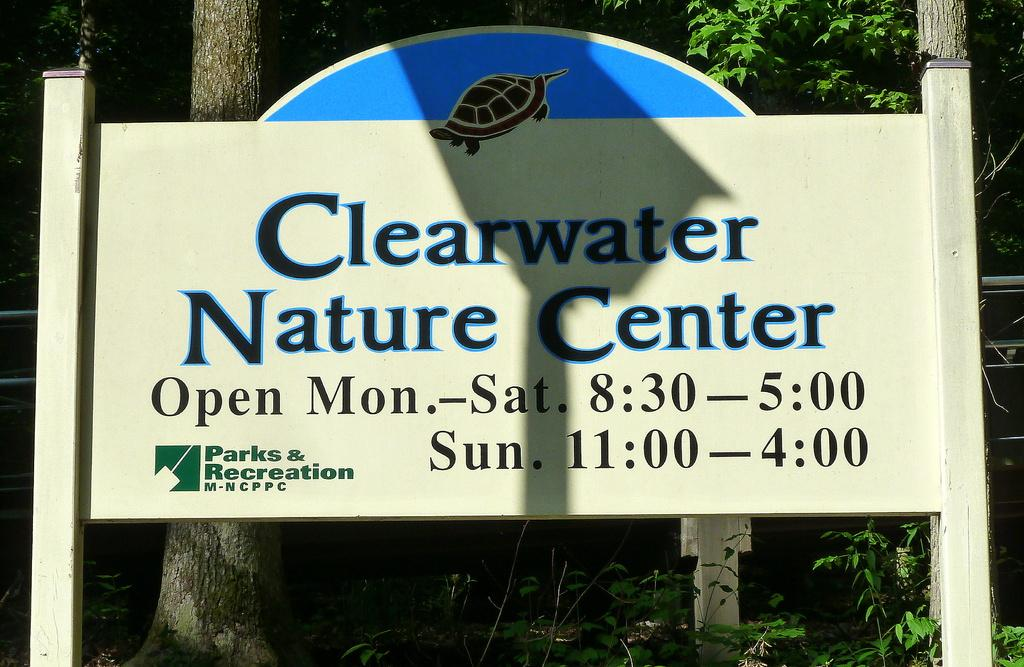What is on the board that is visible in the image? There is a board with writing in the image, and it also has an image of a tortoise on it. What can be seen behind the board in the image? There are trees visible behind the board in the image. Can you tell me how many flowers are on the island in the image? There is no island or flowers present in the image; it features a board with writing and an image of a tortoise, with trees visible behind it. What type of beetle can be seen crawling on the tortoise in the image? There is no beetle present in the image; it only features a board with writing and an image of a tortoise, with trees visible behind it. 